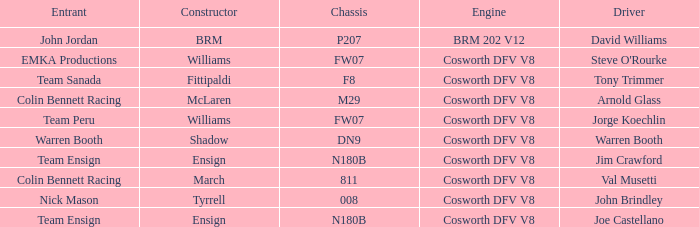What team used the BRM built car? John Jordan. 